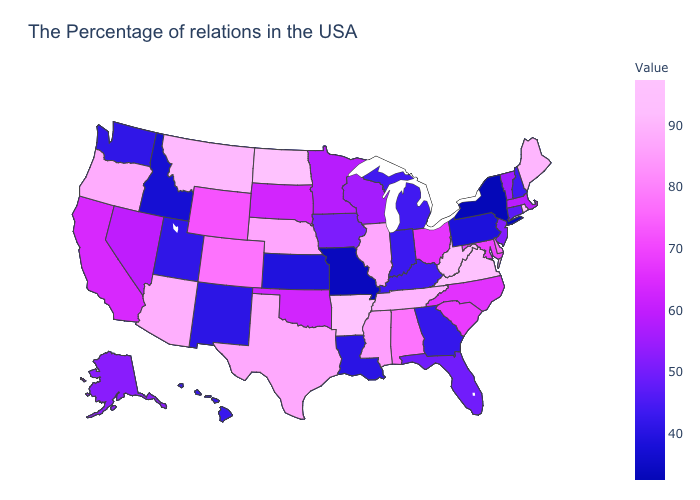Among the states that border Illinois , which have the highest value?
Give a very brief answer. Wisconsin. Does Arkansas have the highest value in the USA?
Answer briefly. Yes. Does Louisiana have the lowest value in the South?
Answer briefly. Yes. 